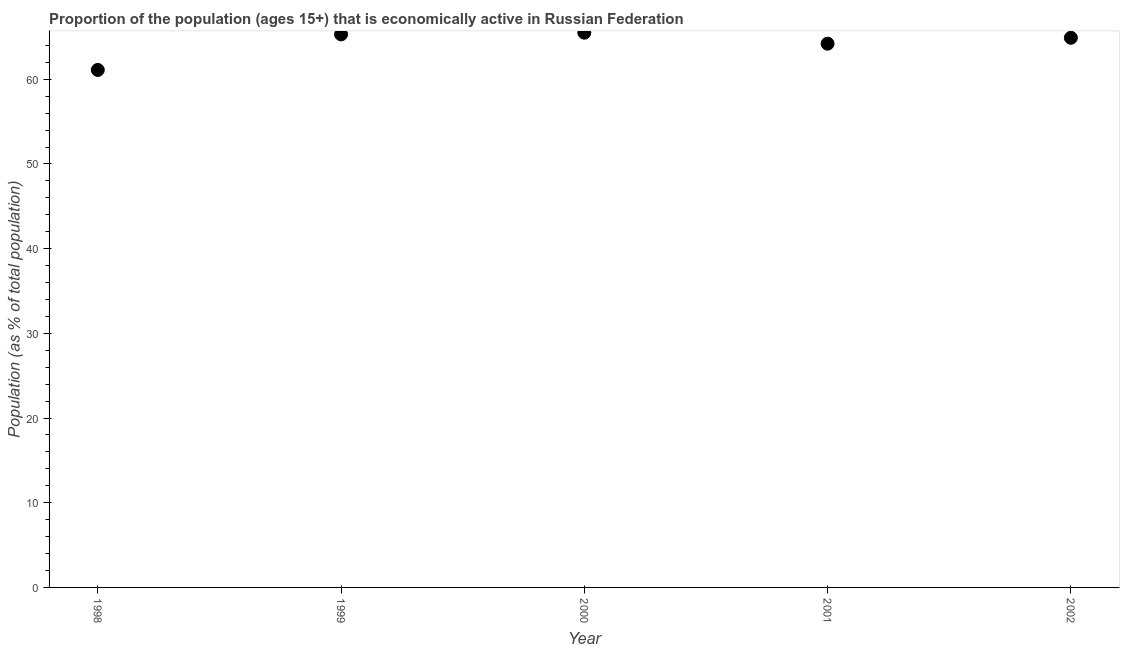What is the percentage of economically active population in 2002?
Offer a terse response. 64.9. Across all years, what is the maximum percentage of economically active population?
Make the answer very short. 65.5. Across all years, what is the minimum percentage of economically active population?
Make the answer very short. 61.1. In which year was the percentage of economically active population maximum?
Your answer should be compact. 2000. In which year was the percentage of economically active population minimum?
Offer a very short reply. 1998. What is the sum of the percentage of economically active population?
Your answer should be very brief. 321. What is the difference between the percentage of economically active population in 1999 and 2000?
Offer a terse response. -0.2. What is the average percentage of economically active population per year?
Your answer should be very brief. 64.2. What is the median percentage of economically active population?
Keep it short and to the point. 64.9. What is the ratio of the percentage of economically active population in 2000 to that in 2001?
Your answer should be very brief. 1.02. Is the percentage of economically active population in 1998 less than that in 2000?
Offer a very short reply. Yes. What is the difference between the highest and the second highest percentage of economically active population?
Keep it short and to the point. 0.2. Is the sum of the percentage of economically active population in 1998 and 2001 greater than the maximum percentage of economically active population across all years?
Your answer should be compact. Yes. What is the difference between the highest and the lowest percentage of economically active population?
Your answer should be very brief. 4.4. In how many years, is the percentage of economically active population greater than the average percentage of economically active population taken over all years?
Keep it short and to the point. 3. Does the percentage of economically active population monotonically increase over the years?
Ensure brevity in your answer.  No. What is the title of the graph?
Give a very brief answer. Proportion of the population (ages 15+) that is economically active in Russian Federation. What is the label or title of the X-axis?
Give a very brief answer. Year. What is the label or title of the Y-axis?
Make the answer very short. Population (as % of total population). What is the Population (as % of total population) in 1998?
Keep it short and to the point. 61.1. What is the Population (as % of total population) in 1999?
Offer a very short reply. 65.3. What is the Population (as % of total population) in 2000?
Give a very brief answer. 65.5. What is the Population (as % of total population) in 2001?
Your answer should be compact. 64.2. What is the Population (as % of total population) in 2002?
Your response must be concise. 64.9. What is the difference between the Population (as % of total population) in 1998 and 2000?
Make the answer very short. -4.4. What is the difference between the Population (as % of total population) in 1999 and 2001?
Your answer should be compact. 1.1. What is the difference between the Population (as % of total population) in 2001 and 2002?
Your answer should be very brief. -0.7. What is the ratio of the Population (as % of total population) in 1998 to that in 1999?
Make the answer very short. 0.94. What is the ratio of the Population (as % of total population) in 1998 to that in 2000?
Provide a succinct answer. 0.93. What is the ratio of the Population (as % of total population) in 1998 to that in 2002?
Keep it short and to the point. 0.94. What is the ratio of the Population (as % of total population) in 1999 to that in 2002?
Keep it short and to the point. 1.01. What is the ratio of the Population (as % of total population) in 2001 to that in 2002?
Your answer should be very brief. 0.99. 